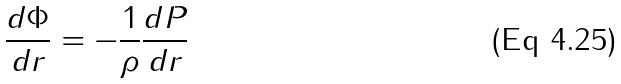Convert formula to latex. <formula><loc_0><loc_0><loc_500><loc_500>\frac { d \Phi } { d r } = - \frac { 1 } { \rho } \frac { d P } { d r }</formula> 